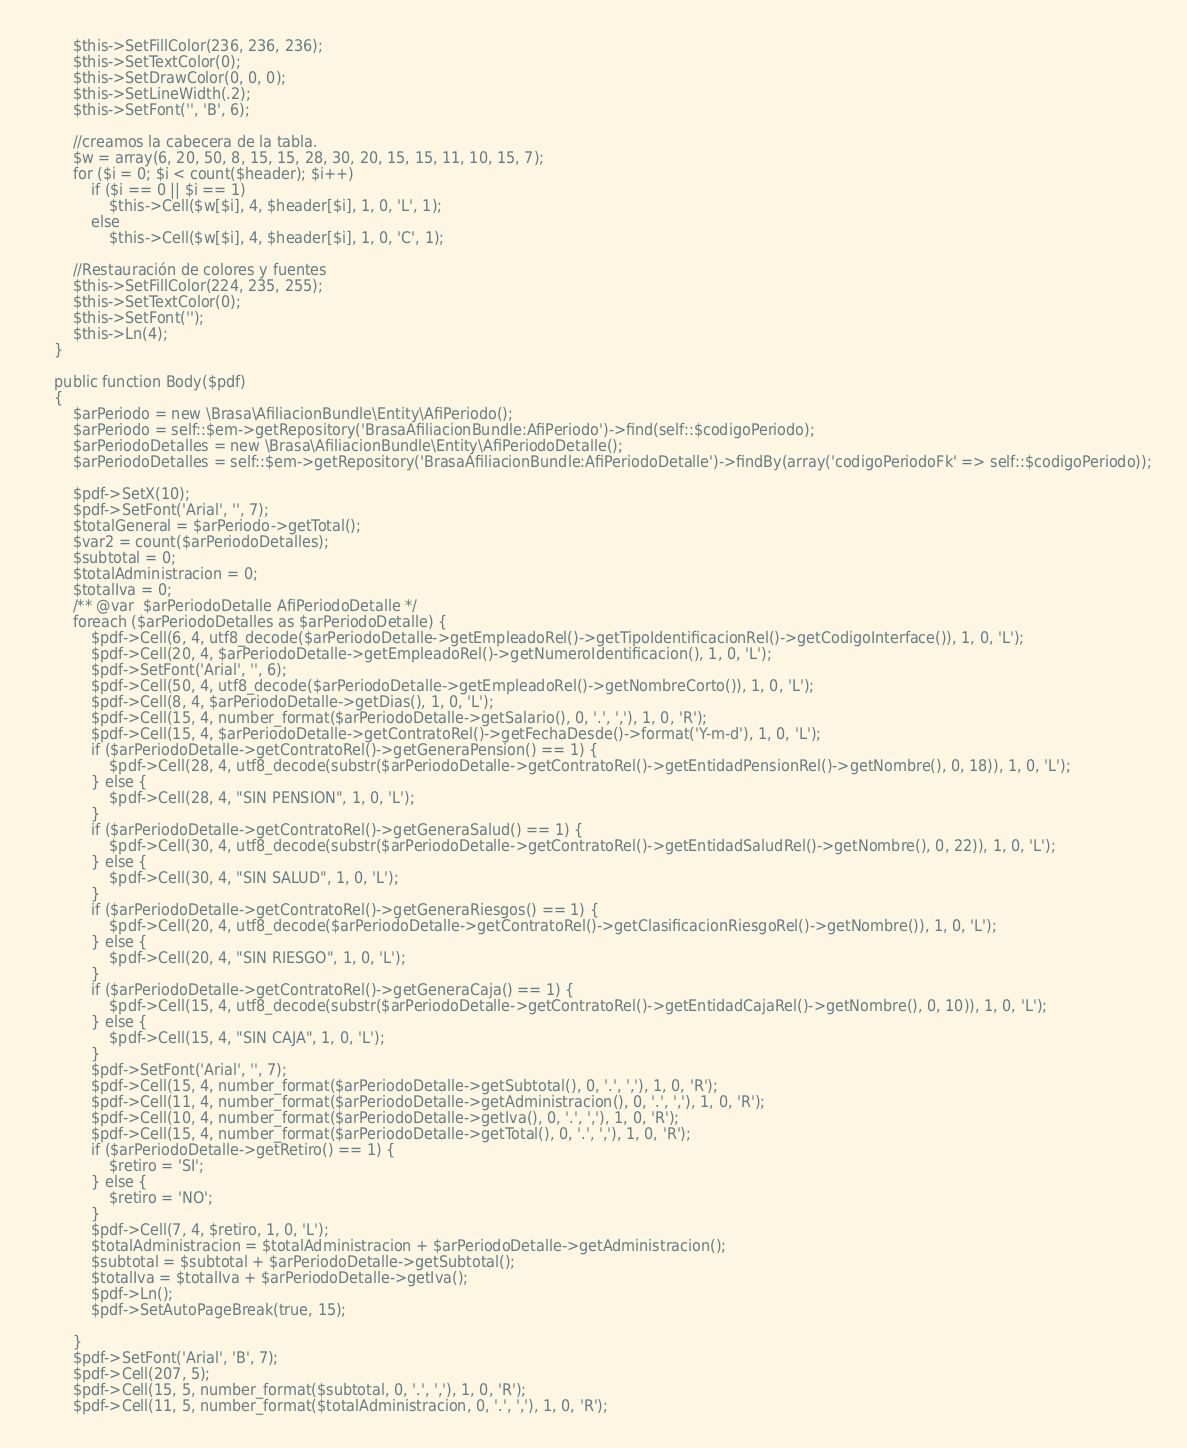Convert code to text. <code><loc_0><loc_0><loc_500><loc_500><_PHP_>        $this->SetFillColor(236, 236, 236);
        $this->SetTextColor(0);
        $this->SetDrawColor(0, 0, 0);
        $this->SetLineWidth(.2);
        $this->SetFont('', 'B', 6);

        //creamos la cabecera de la tabla.
        $w = array(6, 20, 50, 8, 15, 15, 28, 30, 20, 15, 15, 11, 10, 15, 7);
        for ($i = 0; $i < count($header); $i++)
            if ($i == 0 || $i == 1)
                $this->Cell($w[$i], 4, $header[$i], 1, 0, 'L', 1);
            else
                $this->Cell($w[$i], 4, $header[$i], 1, 0, 'C', 1);

        //Restauración de colores y fuentes
        $this->SetFillColor(224, 235, 255);
        $this->SetTextColor(0);
        $this->SetFont('');
        $this->Ln(4);
    }

    public function Body($pdf)
    {
        $arPeriodo = new \Brasa\AfiliacionBundle\Entity\AfiPeriodo();
        $arPeriodo = self::$em->getRepository('BrasaAfiliacionBundle:AfiPeriodo')->find(self::$codigoPeriodo);
        $arPeriodoDetalles = new \Brasa\AfiliacionBundle\Entity\AfiPeriodoDetalle();
        $arPeriodoDetalles = self::$em->getRepository('BrasaAfiliacionBundle:AfiPeriodoDetalle')->findBy(array('codigoPeriodoFk' => self::$codigoPeriodo));

        $pdf->SetX(10);
        $pdf->SetFont('Arial', '', 7);
        $totalGeneral = $arPeriodo->getTotal();
        $var2 = count($arPeriodoDetalles);
        $subtotal = 0;
        $totalAdministracion = 0;
        $totalIva = 0;
        /** @var  $arPeriodoDetalle AfiPeriodoDetalle */
        foreach ($arPeriodoDetalles as $arPeriodoDetalle) {
            $pdf->Cell(6, 4, utf8_decode($arPeriodoDetalle->getEmpleadoRel()->getTipoIdentificacionRel()->getCodigoInterface()), 1, 0, 'L');
            $pdf->Cell(20, 4, $arPeriodoDetalle->getEmpleadoRel()->getNumeroIdentificacion(), 1, 0, 'L');
            $pdf->SetFont('Arial', '', 6);
            $pdf->Cell(50, 4, utf8_decode($arPeriodoDetalle->getEmpleadoRel()->getNombreCorto()), 1, 0, 'L');
            $pdf->Cell(8, 4, $arPeriodoDetalle->getDias(), 1, 0, 'L');
            $pdf->Cell(15, 4, number_format($arPeriodoDetalle->getSalario(), 0, '.', ','), 1, 0, 'R');
            $pdf->Cell(15, 4, $arPeriodoDetalle->getContratoRel()->getFechaDesde()->format('Y-m-d'), 1, 0, 'L');
            if ($arPeriodoDetalle->getContratoRel()->getGeneraPension() == 1) {
                $pdf->Cell(28, 4, utf8_decode(substr($arPeriodoDetalle->getContratoRel()->getEntidadPensionRel()->getNombre(), 0, 18)), 1, 0, 'L');
            } else {
                $pdf->Cell(28, 4, "SIN PENSION", 1, 0, 'L');
            }
            if ($arPeriodoDetalle->getContratoRel()->getGeneraSalud() == 1) {
                $pdf->Cell(30, 4, utf8_decode(substr($arPeriodoDetalle->getContratoRel()->getEntidadSaludRel()->getNombre(), 0, 22)), 1, 0, 'L');
            } else {
                $pdf->Cell(30, 4, "SIN SALUD", 1, 0, 'L');
            }
            if ($arPeriodoDetalle->getContratoRel()->getGeneraRiesgos() == 1) {
                $pdf->Cell(20, 4, utf8_decode($arPeriodoDetalle->getContratoRel()->getClasificacionRiesgoRel()->getNombre()), 1, 0, 'L');
            } else {
                $pdf->Cell(20, 4, "SIN RIESGO", 1, 0, 'L');
            }
            if ($arPeriodoDetalle->getContratoRel()->getGeneraCaja() == 1) {
                $pdf->Cell(15, 4, utf8_decode(substr($arPeriodoDetalle->getContratoRel()->getEntidadCajaRel()->getNombre(), 0, 10)), 1, 0, 'L');
            } else {
                $pdf->Cell(15, 4, "SIN CAJA", 1, 0, 'L');
            }
            $pdf->SetFont('Arial', '', 7);
            $pdf->Cell(15, 4, number_format($arPeriodoDetalle->getSubtotal(), 0, '.', ','), 1, 0, 'R');
            $pdf->Cell(11, 4, number_format($arPeriodoDetalle->getAdministracion(), 0, '.', ','), 1, 0, 'R');
            $pdf->Cell(10, 4, number_format($arPeriodoDetalle->getIva(), 0, '.', ','), 1, 0, 'R');
            $pdf->Cell(15, 4, number_format($arPeriodoDetalle->getTotal(), 0, '.', ','), 1, 0, 'R');
            if ($arPeriodoDetalle->getRetiro() == 1) {
                $retiro = 'SI';
            } else {
                $retiro = 'NO';
            }
            $pdf->Cell(7, 4, $retiro, 1, 0, 'L');
            $totalAdministracion = $totalAdministracion + $arPeriodoDetalle->getAdministracion();
            $subtotal = $subtotal + $arPeriodoDetalle->getSubtotal();
            $totalIva = $totalIva + $arPeriodoDetalle->getIva();
            $pdf->Ln();
            $pdf->SetAutoPageBreak(true, 15);

        }
        $pdf->SetFont('Arial', 'B', 7);
        $pdf->Cell(207, 5);
        $pdf->Cell(15, 5, number_format($subtotal, 0, '.', ','), 1, 0, 'R');
        $pdf->Cell(11, 5, number_format($totalAdministracion, 0, '.', ','), 1, 0, 'R');</code> 